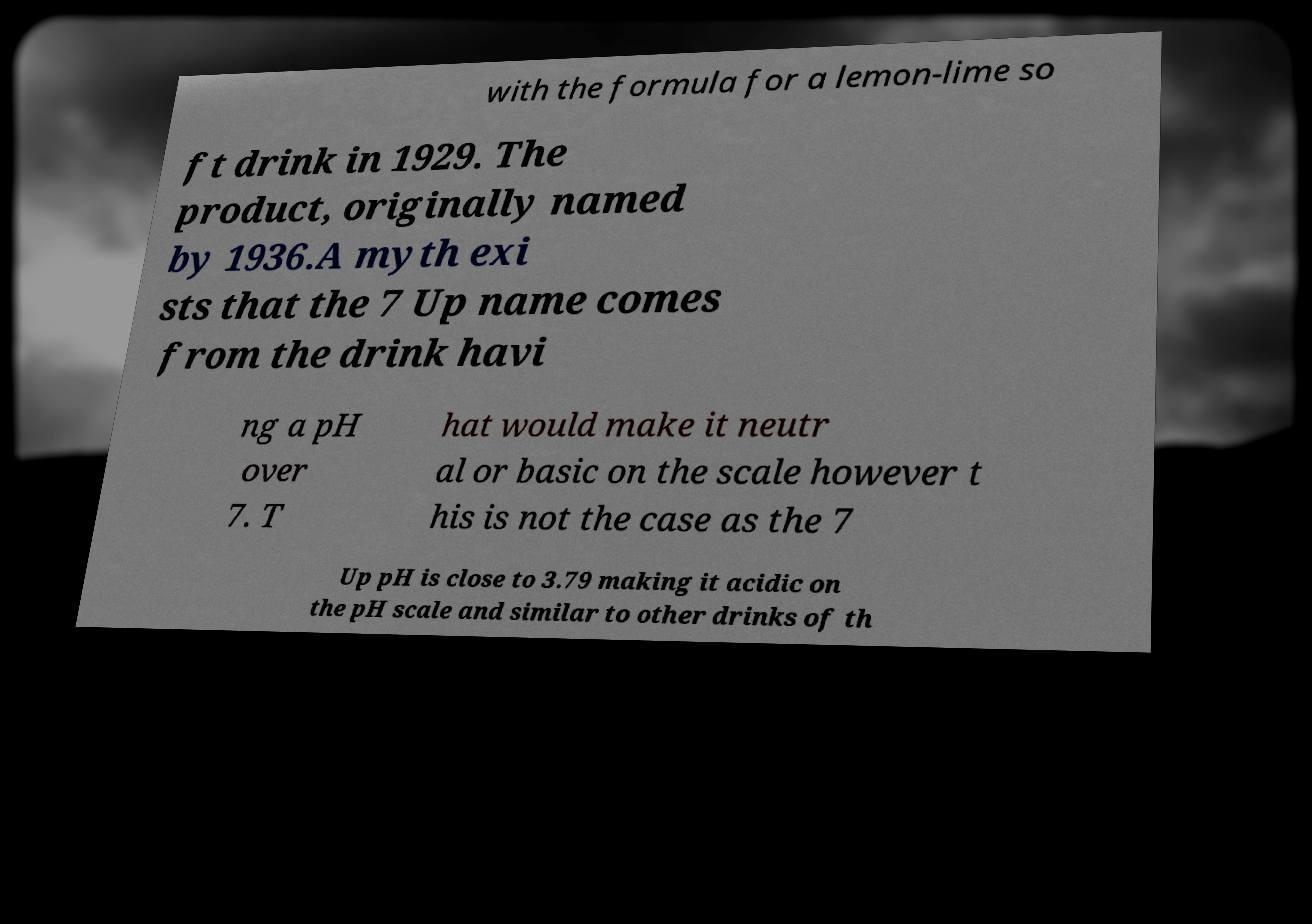Could you assist in decoding the text presented in this image and type it out clearly? with the formula for a lemon-lime so ft drink in 1929. The product, originally named by 1936.A myth exi sts that the 7 Up name comes from the drink havi ng a pH over 7. T hat would make it neutr al or basic on the scale however t his is not the case as the 7 Up pH is close to 3.79 making it acidic on the pH scale and similar to other drinks of th 